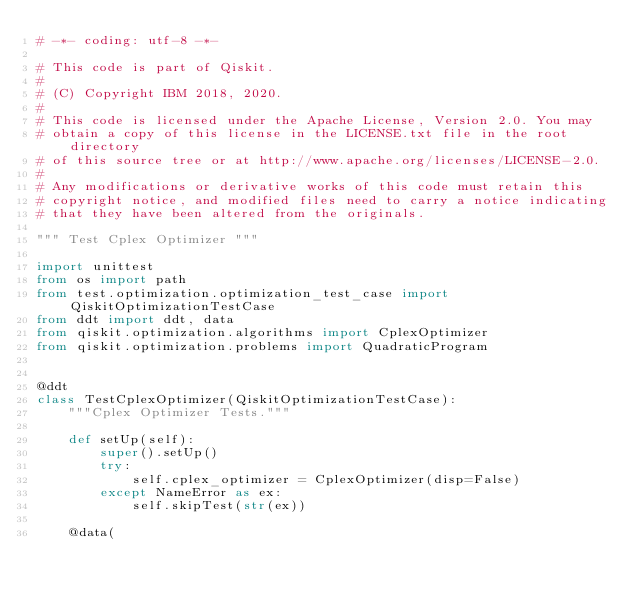<code> <loc_0><loc_0><loc_500><loc_500><_Python_># -*- coding: utf-8 -*-

# This code is part of Qiskit.
#
# (C) Copyright IBM 2018, 2020.
#
# This code is licensed under the Apache License, Version 2.0. You may
# obtain a copy of this license in the LICENSE.txt file in the root directory
# of this source tree or at http://www.apache.org/licenses/LICENSE-2.0.
#
# Any modifications or derivative works of this code must retain this
# copyright notice, and modified files need to carry a notice indicating
# that they have been altered from the originals.

""" Test Cplex Optimizer """

import unittest
from os import path
from test.optimization.optimization_test_case import QiskitOptimizationTestCase
from ddt import ddt, data
from qiskit.optimization.algorithms import CplexOptimizer
from qiskit.optimization.problems import QuadraticProgram


@ddt
class TestCplexOptimizer(QiskitOptimizationTestCase):
    """Cplex Optimizer Tests."""

    def setUp(self):
        super().setUp()
        try:
            self.cplex_optimizer = CplexOptimizer(disp=False)
        except NameError as ex:
            self.skipTest(str(ex))

    @data(</code> 